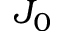Convert formula to latex. <formula><loc_0><loc_0><loc_500><loc_500>J _ { 0 }</formula> 